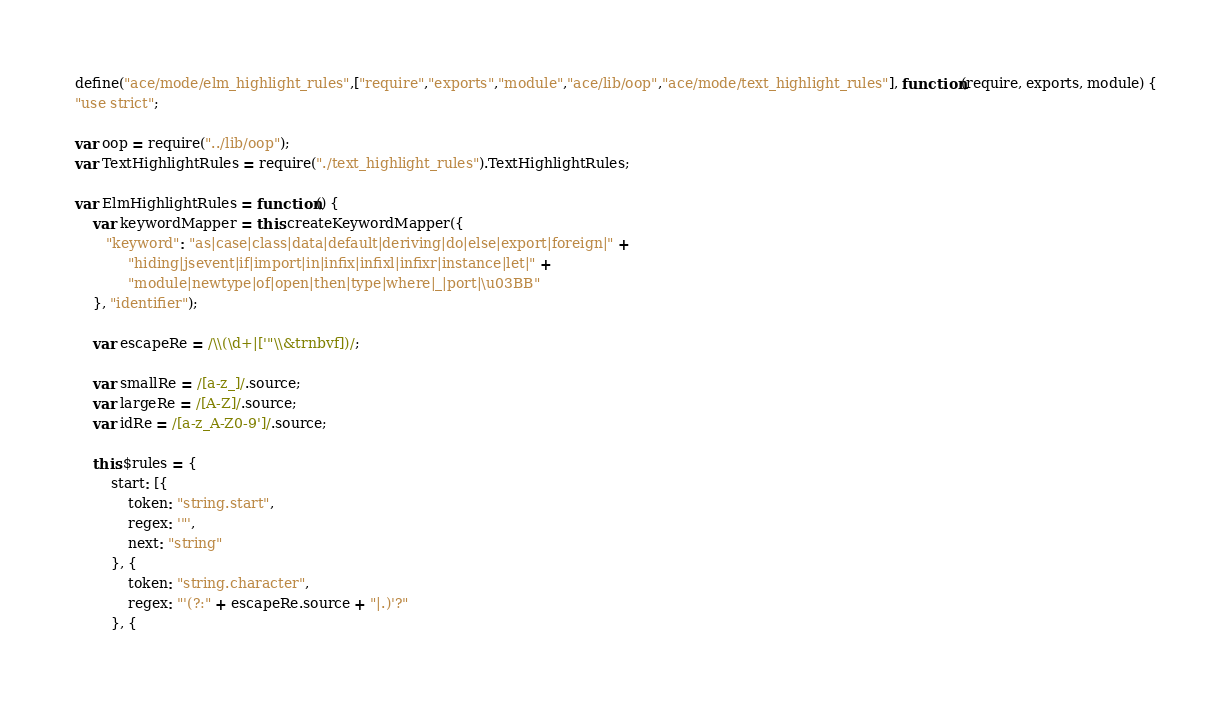<code> <loc_0><loc_0><loc_500><loc_500><_JavaScript_>define("ace/mode/elm_highlight_rules",["require","exports","module","ace/lib/oop","ace/mode/text_highlight_rules"], function(require, exports, module) {
"use strict";

var oop = require("../lib/oop");
var TextHighlightRules = require("./text_highlight_rules").TextHighlightRules;

var ElmHighlightRules = function() {
    var keywordMapper = this.createKeywordMapper({
       "keyword": "as|case|class|data|default|deriving|do|else|export|foreign|" +
            "hiding|jsevent|if|import|in|infix|infixl|infixr|instance|let|" +
            "module|newtype|of|open|then|type|where|_|port|\u03BB"
    }, "identifier");
    
    var escapeRe = /\\(\d+|['"\\&trnbvf])/;
    
    var smallRe = /[a-z_]/.source;
    var largeRe = /[A-Z]/.source;
    var idRe = /[a-z_A-Z0-9']/.source;

    this.$rules = {
        start: [{
            token: "string.start",
            regex: '"',
            next: "string"
        }, {
            token: "string.character",
            regex: "'(?:" + escapeRe.source + "|.)'?"
        }, {</code> 